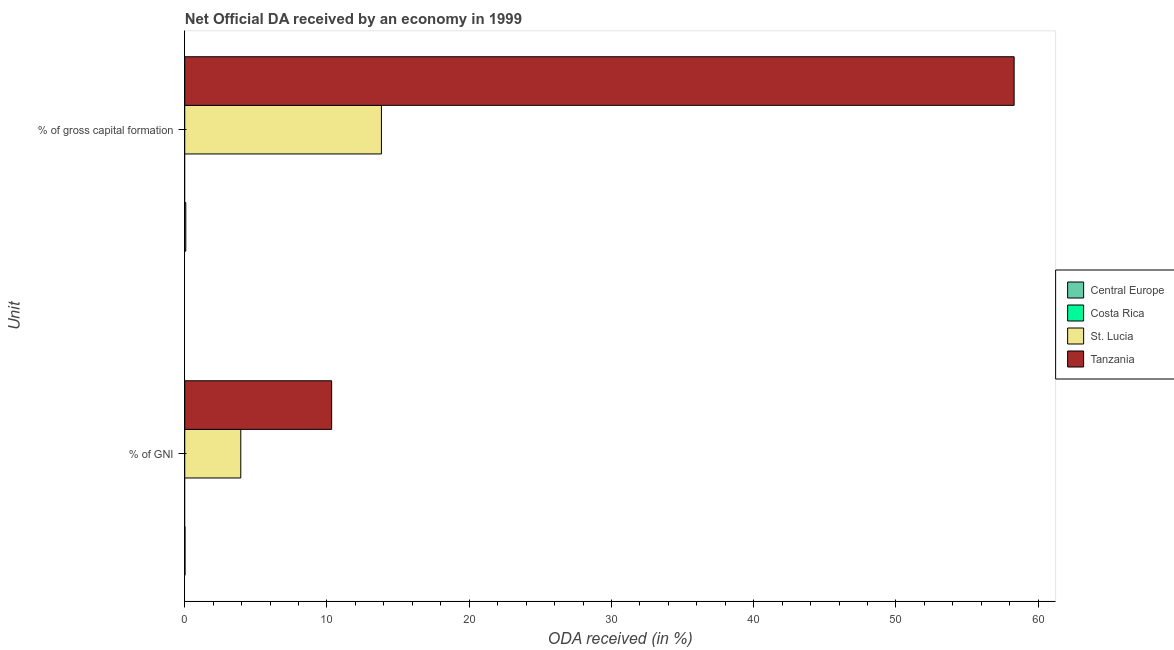How many groups of bars are there?
Your response must be concise. 2. How many bars are there on the 1st tick from the bottom?
Provide a succinct answer. 3. What is the label of the 1st group of bars from the top?
Offer a very short reply. % of gross capital formation. What is the oda received as percentage of gni in Tanzania?
Your answer should be compact. 10.33. Across all countries, what is the maximum oda received as percentage of gross capital formation?
Give a very brief answer. 58.31. In which country was the oda received as percentage of gni maximum?
Ensure brevity in your answer.  Tanzania. What is the total oda received as percentage of gross capital formation in the graph?
Keep it short and to the point. 72.21. What is the difference between the oda received as percentage of gross capital formation in St. Lucia and that in Central Europe?
Your response must be concise. 13.75. What is the difference between the oda received as percentage of gross capital formation in Tanzania and the oda received as percentage of gni in St. Lucia?
Offer a terse response. 54.37. What is the average oda received as percentage of gni per country?
Keep it short and to the point. 3.57. What is the difference between the oda received as percentage of gross capital formation and oda received as percentage of gni in St. Lucia?
Your response must be concise. 9.89. In how many countries, is the oda received as percentage of gross capital formation greater than 6 %?
Give a very brief answer. 2. What is the ratio of the oda received as percentage of gross capital formation in Tanzania to that in Central Europe?
Provide a short and direct response. 798.51. How many bars are there?
Provide a succinct answer. 6. Are all the bars in the graph horizontal?
Ensure brevity in your answer.  Yes. How many countries are there in the graph?
Offer a terse response. 4. What is the difference between two consecutive major ticks on the X-axis?
Ensure brevity in your answer.  10. Does the graph contain any zero values?
Provide a succinct answer. Yes. Does the graph contain grids?
Your response must be concise. No. How are the legend labels stacked?
Provide a short and direct response. Vertical. What is the title of the graph?
Give a very brief answer. Net Official DA received by an economy in 1999. Does "Angola" appear as one of the legend labels in the graph?
Your response must be concise. No. What is the label or title of the X-axis?
Your answer should be compact. ODA received (in %). What is the label or title of the Y-axis?
Offer a very short reply. Unit. What is the ODA received (in %) of Central Europe in % of GNI?
Provide a short and direct response. 0.02. What is the ODA received (in %) in Costa Rica in % of GNI?
Ensure brevity in your answer.  0. What is the ODA received (in %) of St. Lucia in % of GNI?
Offer a terse response. 3.94. What is the ODA received (in %) in Tanzania in % of GNI?
Provide a succinct answer. 10.33. What is the ODA received (in %) of Central Europe in % of gross capital formation?
Make the answer very short. 0.07. What is the ODA received (in %) of St. Lucia in % of gross capital formation?
Offer a very short reply. 13.83. What is the ODA received (in %) of Tanzania in % of gross capital formation?
Provide a succinct answer. 58.31. Across all Unit, what is the maximum ODA received (in %) in Central Europe?
Your response must be concise. 0.07. Across all Unit, what is the maximum ODA received (in %) of St. Lucia?
Ensure brevity in your answer.  13.83. Across all Unit, what is the maximum ODA received (in %) of Tanzania?
Offer a terse response. 58.31. Across all Unit, what is the minimum ODA received (in %) in Central Europe?
Your response must be concise. 0.02. Across all Unit, what is the minimum ODA received (in %) in St. Lucia?
Offer a very short reply. 3.94. Across all Unit, what is the minimum ODA received (in %) in Tanzania?
Offer a terse response. 10.33. What is the total ODA received (in %) in Central Europe in the graph?
Ensure brevity in your answer.  0.09. What is the total ODA received (in %) in Costa Rica in the graph?
Keep it short and to the point. 0. What is the total ODA received (in %) of St. Lucia in the graph?
Keep it short and to the point. 17.77. What is the total ODA received (in %) of Tanzania in the graph?
Provide a succinct answer. 68.64. What is the difference between the ODA received (in %) of Central Europe in % of GNI and that in % of gross capital formation?
Your response must be concise. -0.05. What is the difference between the ODA received (in %) of St. Lucia in % of GNI and that in % of gross capital formation?
Give a very brief answer. -9.89. What is the difference between the ODA received (in %) of Tanzania in % of GNI and that in % of gross capital formation?
Your answer should be compact. -47.98. What is the difference between the ODA received (in %) of Central Europe in % of GNI and the ODA received (in %) of St. Lucia in % of gross capital formation?
Keep it short and to the point. -13.81. What is the difference between the ODA received (in %) of Central Europe in % of GNI and the ODA received (in %) of Tanzania in % of gross capital formation?
Make the answer very short. -58.29. What is the difference between the ODA received (in %) of St. Lucia in % of GNI and the ODA received (in %) of Tanzania in % of gross capital formation?
Give a very brief answer. -54.37. What is the average ODA received (in %) in Central Europe per Unit?
Give a very brief answer. 0.05. What is the average ODA received (in %) in St. Lucia per Unit?
Offer a terse response. 8.88. What is the average ODA received (in %) in Tanzania per Unit?
Provide a short and direct response. 34.32. What is the difference between the ODA received (in %) in Central Europe and ODA received (in %) in St. Lucia in % of GNI?
Offer a terse response. -3.92. What is the difference between the ODA received (in %) of Central Europe and ODA received (in %) of Tanzania in % of GNI?
Give a very brief answer. -10.31. What is the difference between the ODA received (in %) of St. Lucia and ODA received (in %) of Tanzania in % of GNI?
Provide a succinct answer. -6.39. What is the difference between the ODA received (in %) of Central Europe and ODA received (in %) of St. Lucia in % of gross capital formation?
Your answer should be very brief. -13.75. What is the difference between the ODA received (in %) in Central Europe and ODA received (in %) in Tanzania in % of gross capital formation?
Your response must be concise. -58.24. What is the difference between the ODA received (in %) of St. Lucia and ODA received (in %) of Tanzania in % of gross capital formation?
Your response must be concise. -44.48. What is the ratio of the ODA received (in %) of Central Europe in % of GNI to that in % of gross capital formation?
Your answer should be very brief. 0.25. What is the ratio of the ODA received (in %) in St. Lucia in % of GNI to that in % of gross capital formation?
Your response must be concise. 0.28. What is the ratio of the ODA received (in %) of Tanzania in % of GNI to that in % of gross capital formation?
Ensure brevity in your answer.  0.18. What is the difference between the highest and the second highest ODA received (in %) of Central Europe?
Give a very brief answer. 0.05. What is the difference between the highest and the second highest ODA received (in %) of St. Lucia?
Provide a succinct answer. 9.89. What is the difference between the highest and the second highest ODA received (in %) in Tanzania?
Your response must be concise. 47.98. What is the difference between the highest and the lowest ODA received (in %) in Central Europe?
Offer a terse response. 0.05. What is the difference between the highest and the lowest ODA received (in %) in St. Lucia?
Your answer should be compact. 9.89. What is the difference between the highest and the lowest ODA received (in %) of Tanzania?
Provide a short and direct response. 47.98. 